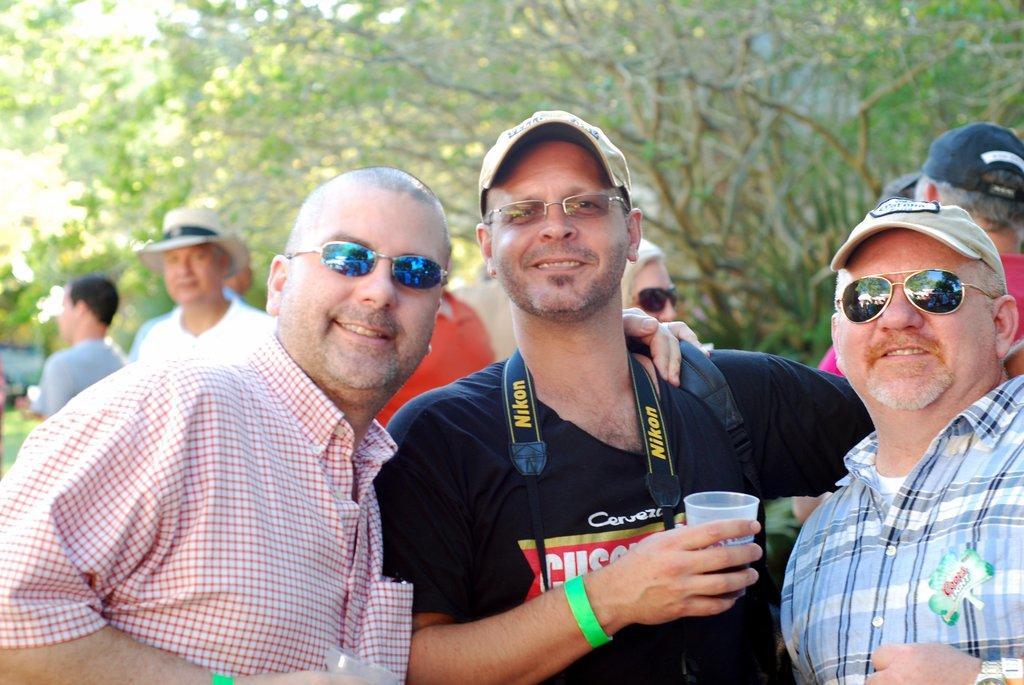In one or two sentences, can you explain what this image depicts? In this image I can see the group of people with different color dresses and few people are wearing the caps and hat. I can also see few people with the goggles and specs. I can see two people are holding the glasses. In the background there are many trees. 